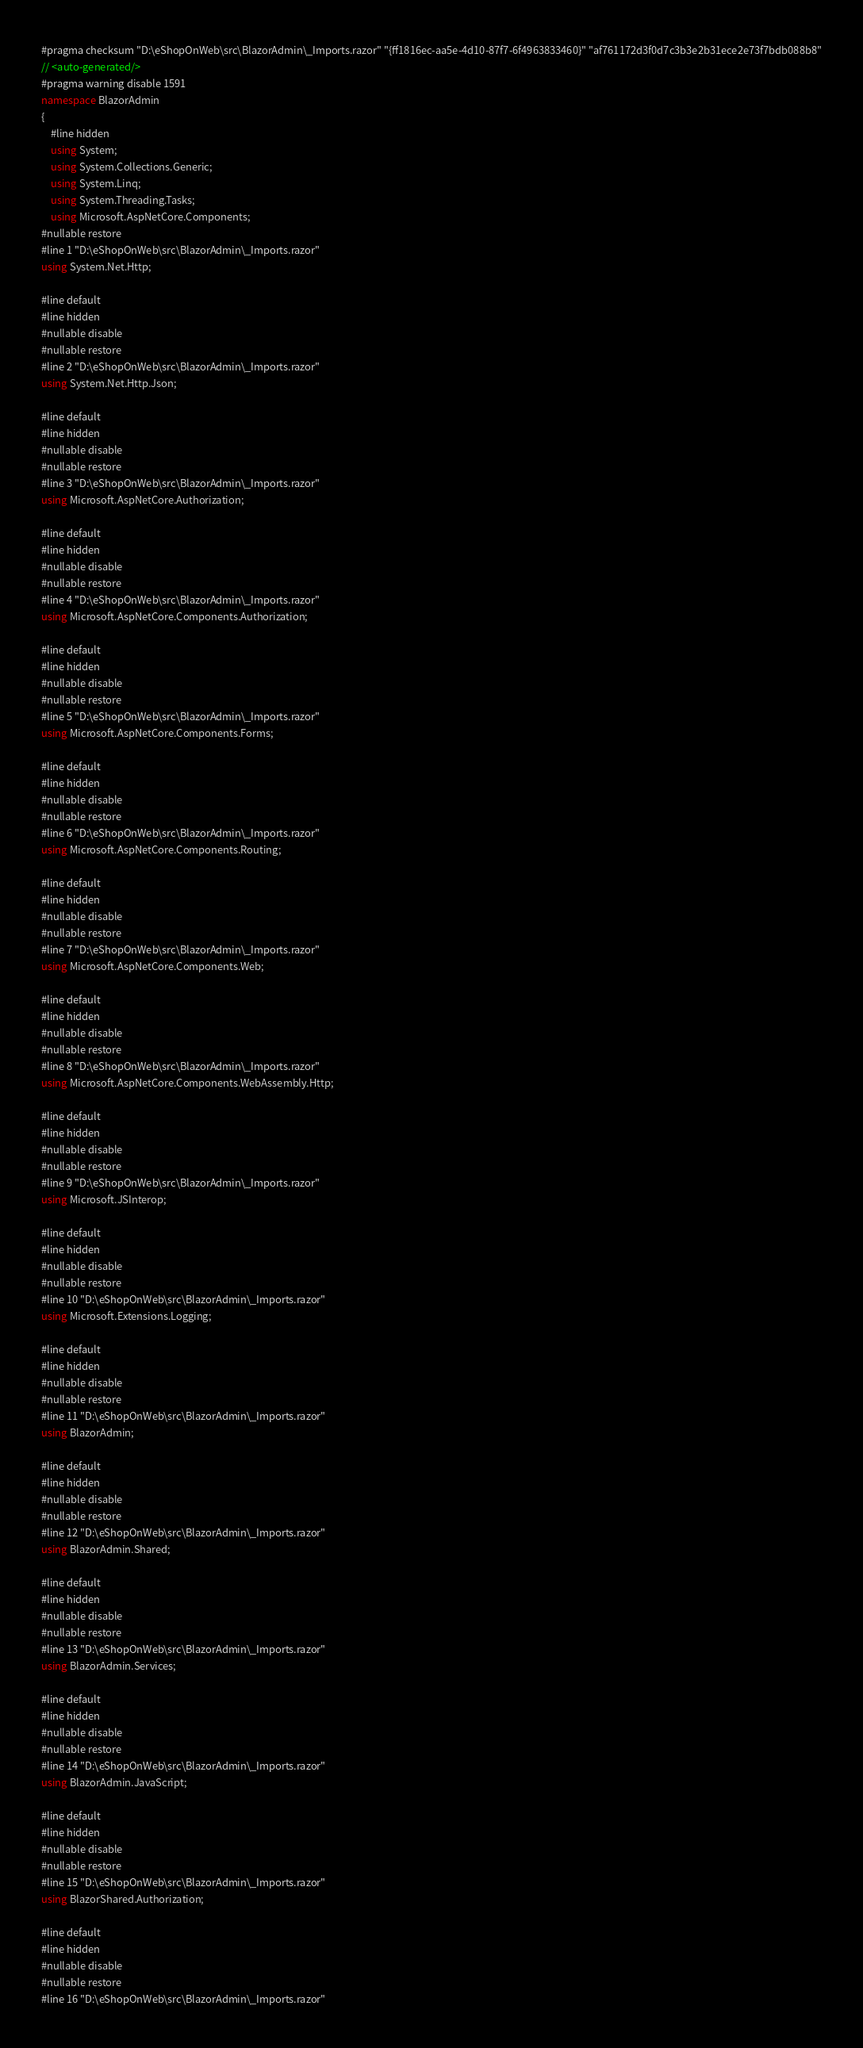Convert code to text. <code><loc_0><loc_0><loc_500><loc_500><_C#_>#pragma checksum "D:\eShopOnWeb\src\BlazorAdmin\_Imports.razor" "{ff1816ec-aa5e-4d10-87f7-6f4963833460}" "af761172d3f0d7c3b3e2b31ece2e73f7bdb088b8"
// <auto-generated/>
#pragma warning disable 1591
namespace BlazorAdmin
{
    #line hidden
    using System;
    using System.Collections.Generic;
    using System.Linq;
    using System.Threading.Tasks;
    using Microsoft.AspNetCore.Components;
#nullable restore
#line 1 "D:\eShopOnWeb\src\BlazorAdmin\_Imports.razor"
using System.Net.Http;

#line default
#line hidden
#nullable disable
#nullable restore
#line 2 "D:\eShopOnWeb\src\BlazorAdmin\_Imports.razor"
using System.Net.Http.Json;

#line default
#line hidden
#nullable disable
#nullable restore
#line 3 "D:\eShopOnWeb\src\BlazorAdmin\_Imports.razor"
using Microsoft.AspNetCore.Authorization;

#line default
#line hidden
#nullable disable
#nullable restore
#line 4 "D:\eShopOnWeb\src\BlazorAdmin\_Imports.razor"
using Microsoft.AspNetCore.Components.Authorization;

#line default
#line hidden
#nullable disable
#nullable restore
#line 5 "D:\eShopOnWeb\src\BlazorAdmin\_Imports.razor"
using Microsoft.AspNetCore.Components.Forms;

#line default
#line hidden
#nullable disable
#nullable restore
#line 6 "D:\eShopOnWeb\src\BlazorAdmin\_Imports.razor"
using Microsoft.AspNetCore.Components.Routing;

#line default
#line hidden
#nullable disable
#nullable restore
#line 7 "D:\eShopOnWeb\src\BlazorAdmin\_Imports.razor"
using Microsoft.AspNetCore.Components.Web;

#line default
#line hidden
#nullable disable
#nullable restore
#line 8 "D:\eShopOnWeb\src\BlazorAdmin\_Imports.razor"
using Microsoft.AspNetCore.Components.WebAssembly.Http;

#line default
#line hidden
#nullable disable
#nullable restore
#line 9 "D:\eShopOnWeb\src\BlazorAdmin\_Imports.razor"
using Microsoft.JSInterop;

#line default
#line hidden
#nullable disable
#nullable restore
#line 10 "D:\eShopOnWeb\src\BlazorAdmin\_Imports.razor"
using Microsoft.Extensions.Logging;

#line default
#line hidden
#nullable disable
#nullable restore
#line 11 "D:\eShopOnWeb\src\BlazorAdmin\_Imports.razor"
using BlazorAdmin;

#line default
#line hidden
#nullable disable
#nullable restore
#line 12 "D:\eShopOnWeb\src\BlazorAdmin\_Imports.razor"
using BlazorAdmin.Shared;

#line default
#line hidden
#nullable disable
#nullable restore
#line 13 "D:\eShopOnWeb\src\BlazorAdmin\_Imports.razor"
using BlazorAdmin.Services;

#line default
#line hidden
#nullable disable
#nullable restore
#line 14 "D:\eShopOnWeb\src\BlazorAdmin\_Imports.razor"
using BlazorAdmin.JavaScript;

#line default
#line hidden
#nullable disable
#nullable restore
#line 15 "D:\eShopOnWeb\src\BlazorAdmin\_Imports.razor"
using BlazorShared.Authorization;

#line default
#line hidden
#nullable disable
#nullable restore
#line 16 "D:\eShopOnWeb\src\BlazorAdmin\_Imports.razor"</code> 